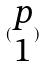Convert formula to latex. <formula><loc_0><loc_0><loc_500><loc_500>( \begin{matrix} p \\ 1 \end{matrix} )</formula> 